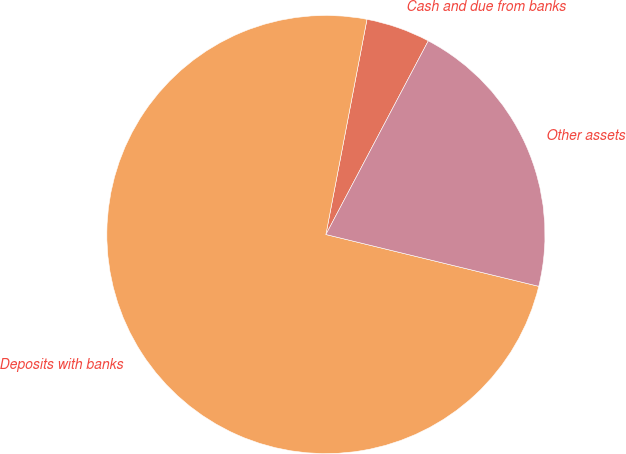Convert chart to OTSL. <chart><loc_0><loc_0><loc_500><loc_500><pie_chart><fcel>Cash and due from banks<fcel>Deposits with banks<fcel>Other assets<nl><fcel>4.74%<fcel>74.2%<fcel>21.06%<nl></chart> 